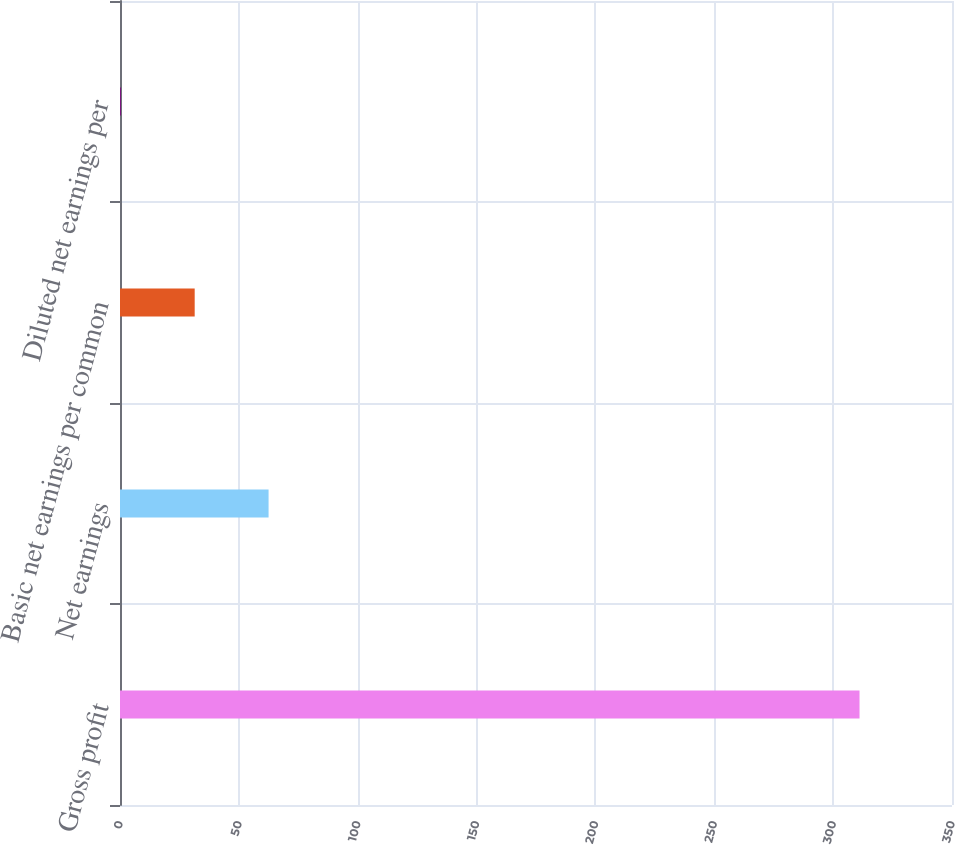<chart> <loc_0><loc_0><loc_500><loc_500><bar_chart><fcel>Gross profit<fcel>Net earnings<fcel>Basic net earnings per common<fcel>Diluted net earnings per<nl><fcel>311.1<fcel>62.5<fcel>31.42<fcel>0.34<nl></chart> 